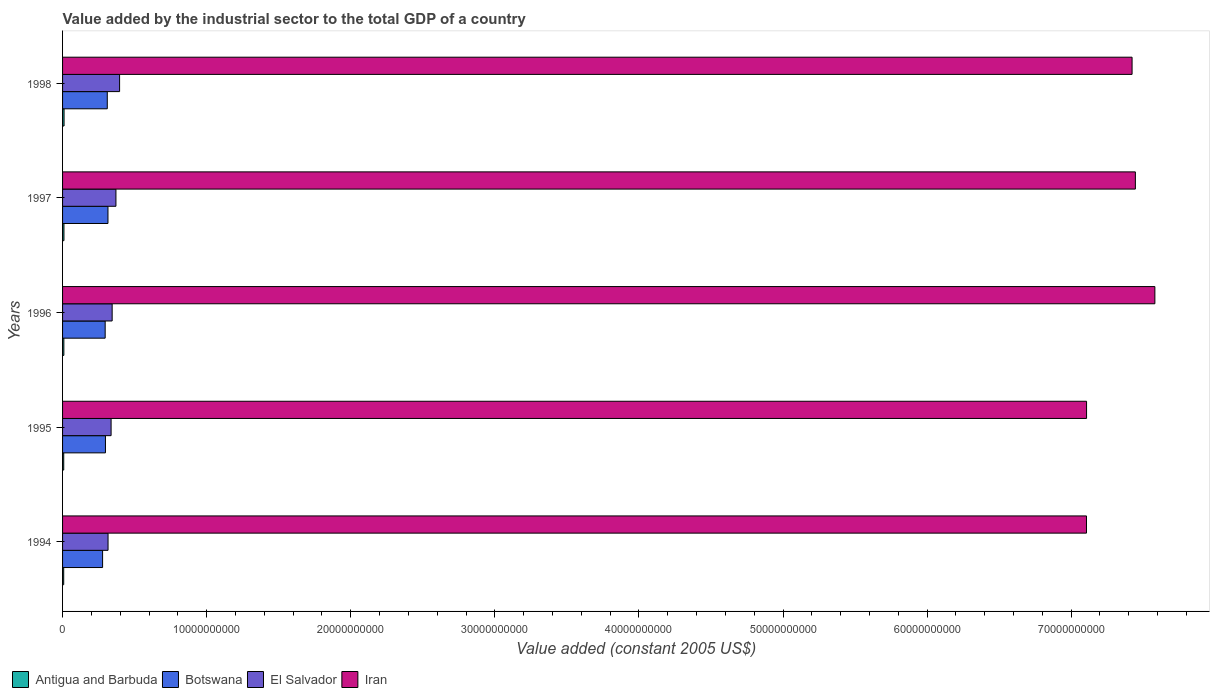Are the number of bars per tick equal to the number of legend labels?
Give a very brief answer. Yes. Are the number of bars on each tick of the Y-axis equal?
Provide a succinct answer. Yes. How many bars are there on the 3rd tick from the top?
Provide a succinct answer. 4. How many bars are there on the 4th tick from the bottom?
Offer a very short reply. 4. In how many cases, is the number of bars for a given year not equal to the number of legend labels?
Your response must be concise. 0. What is the value added by the industrial sector in El Salvador in 1995?
Keep it short and to the point. 3.37e+09. Across all years, what is the maximum value added by the industrial sector in El Salvador?
Offer a very short reply. 3.96e+09. Across all years, what is the minimum value added by the industrial sector in Botswana?
Your response must be concise. 2.78e+09. In which year was the value added by the industrial sector in Antigua and Barbuda minimum?
Make the answer very short. 1994. What is the total value added by the industrial sector in El Salvador in the graph?
Your response must be concise. 1.76e+1. What is the difference between the value added by the industrial sector in El Salvador in 1995 and that in 1996?
Offer a terse response. -7.37e+07. What is the difference between the value added by the industrial sector in Antigua and Barbuda in 1997 and the value added by the industrial sector in Iran in 1995?
Provide a succinct answer. -7.10e+1. What is the average value added by the industrial sector in Antigua and Barbuda per year?
Your response must be concise. 8.99e+07. In the year 1994, what is the difference between the value added by the industrial sector in El Salvador and value added by the industrial sector in Botswana?
Ensure brevity in your answer.  3.79e+08. In how many years, is the value added by the industrial sector in Iran greater than 76000000000 US$?
Make the answer very short. 0. What is the ratio of the value added by the industrial sector in Antigua and Barbuda in 1996 to that in 1997?
Your response must be concise. 0.93. What is the difference between the highest and the second highest value added by the industrial sector in Antigua and Barbuda?
Provide a succinct answer. 7.45e+06. What is the difference between the highest and the lowest value added by the industrial sector in Botswana?
Your response must be concise. 3.73e+08. Is the sum of the value added by the industrial sector in El Salvador in 1994 and 1997 greater than the maximum value added by the industrial sector in Botswana across all years?
Make the answer very short. Yes. Is it the case that in every year, the sum of the value added by the industrial sector in El Salvador and value added by the industrial sector in Botswana is greater than the sum of value added by the industrial sector in Antigua and Barbuda and value added by the industrial sector in Iran?
Provide a short and direct response. Yes. What does the 2nd bar from the top in 1994 represents?
Give a very brief answer. El Salvador. What does the 1st bar from the bottom in 1995 represents?
Ensure brevity in your answer.  Antigua and Barbuda. How many bars are there?
Offer a terse response. 20. What is the difference between two consecutive major ticks on the X-axis?
Your answer should be very brief. 1.00e+1. Does the graph contain any zero values?
Your response must be concise. No. Where does the legend appear in the graph?
Your answer should be compact. Bottom left. How many legend labels are there?
Offer a terse response. 4. What is the title of the graph?
Offer a very short reply. Value added by the industrial sector to the total GDP of a country. Does "Nepal" appear as one of the legend labels in the graph?
Your answer should be very brief. No. What is the label or title of the X-axis?
Offer a terse response. Value added (constant 2005 US$). What is the label or title of the Y-axis?
Make the answer very short. Years. What is the Value added (constant 2005 US$) of Antigua and Barbuda in 1994?
Keep it short and to the point. 7.94e+07. What is the Value added (constant 2005 US$) of Botswana in 1994?
Keep it short and to the point. 2.78e+09. What is the Value added (constant 2005 US$) in El Salvador in 1994?
Your response must be concise. 3.16e+09. What is the Value added (constant 2005 US$) in Iran in 1994?
Keep it short and to the point. 7.11e+1. What is the Value added (constant 2005 US$) of Antigua and Barbuda in 1995?
Ensure brevity in your answer.  8.10e+07. What is the Value added (constant 2005 US$) of Botswana in 1995?
Make the answer very short. 2.98e+09. What is the Value added (constant 2005 US$) of El Salvador in 1995?
Provide a succinct answer. 3.37e+09. What is the Value added (constant 2005 US$) of Iran in 1995?
Make the answer very short. 7.11e+1. What is the Value added (constant 2005 US$) of Antigua and Barbuda in 1996?
Give a very brief answer. 8.97e+07. What is the Value added (constant 2005 US$) in Botswana in 1996?
Keep it short and to the point. 2.96e+09. What is the Value added (constant 2005 US$) of El Salvador in 1996?
Keep it short and to the point. 3.44e+09. What is the Value added (constant 2005 US$) of Iran in 1996?
Make the answer very short. 7.58e+1. What is the Value added (constant 2005 US$) of Antigua and Barbuda in 1997?
Your response must be concise. 9.61e+07. What is the Value added (constant 2005 US$) of Botswana in 1997?
Offer a very short reply. 3.15e+09. What is the Value added (constant 2005 US$) in El Salvador in 1997?
Keep it short and to the point. 3.70e+09. What is the Value added (constant 2005 US$) in Iran in 1997?
Make the answer very short. 7.45e+1. What is the Value added (constant 2005 US$) in Antigua and Barbuda in 1998?
Offer a terse response. 1.04e+08. What is the Value added (constant 2005 US$) in Botswana in 1998?
Keep it short and to the point. 3.10e+09. What is the Value added (constant 2005 US$) of El Salvador in 1998?
Your answer should be very brief. 3.96e+09. What is the Value added (constant 2005 US$) in Iran in 1998?
Provide a short and direct response. 7.42e+1. Across all years, what is the maximum Value added (constant 2005 US$) of Antigua and Barbuda?
Offer a terse response. 1.04e+08. Across all years, what is the maximum Value added (constant 2005 US$) in Botswana?
Your answer should be very brief. 3.15e+09. Across all years, what is the maximum Value added (constant 2005 US$) of El Salvador?
Provide a short and direct response. 3.96e+09. Across all years, what is the maximum Value added (constant 2005 US$) of Iran?
Give a very brief answer. 7.58e+1. Across all years, what is the minimum Value added (constant 2005 US$) in Antigua and Barbuda?
Ensure brevity in your answer.  7.94e+07. Across all years, what is the minimum Value added (constant 2005 US$) of Botswana?
Offer a very short reply. 2.78e+09. Across all years, what is the minimum Value added (constant 2005 US$) of El Salvador?
Your response must be concise. 3.16e+09. Across all years, what is the minimum Value added (constant 2005 US$) of Iran?
Your answer should be very brief. 7.11e+1. What is the total Value added (constant 2005 US$) of Antigua and Barbuda in the graph?
Keep it short and to the point. 4.50e+08. What is the total Value added (constant 2005 US$) of Botswana in the graph?
Provide a short and direct response. 1.50e+1. What is the total Value added (constant 2005 US$) in El Salvador in the graph?
Ensure brevity in your answer.  1.76e+1. What is the total Value added (constant 2005 US$) of Iran in the graph?
Ensure brevity in your answer.  3.67e+11. What is the difference between the Value added (constant 2005 US$) in Antigua and Barbuda in 1994 and that in 1995?
Offer a very short reply. -1.69e+06. What is the difference between the Value added (constant 2005 US$) of Botswana in 1994 and that in 1995?
Ensure brevity in your answer.  -1.98e+08. What is the difference between the Value added (constant 2005 US$) in El Salvador in 1994 and that in 1995?
Ensure brevity in your answer.  -2.11e+08. What is the difference between the Value added (constant 2005 US$) of Iran in 1994 and that in 1995?
Make the answer very short. -5.44e+06. What is the difference between the Value added (constant 2005 US$) of Antigua and Barbuda in 1994 and that in 1996?
Give a very brief answer. -1.03e+07. What is the difference between the Value added (constant 2005 US$) of Botswana in 1994 and that in 1996?
Your answer should be very brief. -1.79e+08. What is the difference between the Value added (constant 2005 US$) in El Salvador in 1994 and that in 1996?
Give a very brief answer. -2.85e+08. What is the difference between the Value added (constant 2005 US$) in Iran in 1994 and that in 1996?
Keep it short and to the point. -4.75e+09. What is the difference between the Value added (constant 2005 US$) of Antigua and Barbuda in 1994 and that in 1997?
Your response must be concise. -1.67e+07. What is the difference between the Value added (constant 2005 US$) in Botswana in 1994 and that in 1997?
Your answer should be compact. -3.73e+08. What is the difference between the Value added (constant 2005 US$) of El Salvador in 1994 and that in 1997?
Your answer should be compact. -5.47e+08. What is the difference between the Value added (constant 2005 US$) in Iran in 1994 and that in 1997?
Provide a short and direct response. -3.39e+09. What is the difference between the Value added (constant 2005 US$) in Antigua and Barbuda in 1994 and that in 1998?
Give a very brief answer. -2.42e+07. What is the difference between the Value added (constant 2005 US$) in Botswana in 1994 and that in 1998?
Offer a very short reply. -3.25e+08. What is the difference between the Value added (constant 2005 US$) in El Salvador in 1994 and that in 1998?
Your answer should be compact. -8.01e+08. What is the difference between the Value added (constant 2005 US$) of Iran in 1994 and that in 1998?
Keep it short and to the point. -3.16e+09. What is the difference between the Value added (constant 2005 US$) of Antigua and Barbuda in 1995 and that in 1996?
Make the answer very short. -8.63e+06. What is the difference between the Value added (constant 2005 US$) of Botswana in 1995 and that in 1996?
Ensure brevity in your answer.  1.96e+07. What is the difference between the Value added (constant 2005 US$) in El Salvador in 1995 and that in 1996?
Provide a short and direct response. -7.37e+07. What is the difference between the Value added (constant 2005 US$) in Iran in 1995 and that in 1996?
Ensure brevity in your answer.  -4.74e+09. What is the difference between the Value added (constant 2005 US$) in Antigua and Barbuda in 1995 and that in 1997?
Ensure brevity in your answer.  -1.50e+07. What is the difference between the Value added (constant 2005 US$) of Botswana in 1995 and that in 1997?
Offer a terse response. -1.75e+08. What is the difference between the Value added (constant 2005 US$) in El Salvador in 1995 and that in 1997?
Provide a succinct answer. -3.36e+08. What is the difference between the Value added (constant 2005 US$) in Iran in 1995 and that in 1997?
Ensure brevity in your answer.  -3.39e+09. What is the difference between the Value added (constant 2005 US$) in Antigua and Barbuda in 1995 and that in 1998?
Your response must be concise. -2.25e+07. What is the difference between the Value added (constant 2005 US$) in Botswana in 1995 and that in 1998?
Ensure brevity in your answer.  -1.27e+08. What is the difference between the Value added (constant 2005 US$) in El Salvador in 1995 and that in 1998?
Keep it short and to the point. -5.90e+08. What is the difference between the Value added (constant 2005 US$) in Iran in 1995 and that in 1998?
Your answer should be compact. -3.16e+09. What is the difference between the Value added (constant 2005 US$) in Antigua and Barbuda in 1996 and that in 1997?
Make the answer very short. -6.40e+06. What is the difference between the Value added (constant 2005 US$) in Botswana in 1996 and that in 1997?
Offer a terse response. -1.94e+08. What is the difference between the Value added (constant 2005 US$) of El Salvador in 1996 and that in 1997?
Your answer should be compact. -2.62e+08. What is the difference between the Value added (constant 2005 US$) in Iran in 1996 and that in 1997?
Offer a very short reply. 1.35e+09. What is the difference between the Value added (constant 2005 US$) in Antigua and Barbuda in 1996 and that in 1998?
Give a very brief answer. -1.38e+07. What is the difference between the Value added (constant 2005 US$) of Botswana in 1996 and that in 1998?
Keep it short and to the point. -1.46e+08. What is the difference between the Value added (constant 2005 US$) in El Salvador in 1996 and that in 1998?
Your response must be concise. -5.16e+08. What is the difference between the Value added (constant 2005 US$) in Iran in 1996 and that in 1998?
Offer a terse response. 1.58e+09. What is the difference between the Value added (constant 2005 US$) of Antigua and Barbuda in 1997 and that in 1998?
Ensure brevity in your answer.  -7.45e+06. What is the difference between the Value added (constant 2005 US$) of Botswana in 1997 and that in 1998?
Give a very brief answer. 4.81e+07. What is the difference between the Value added (constant 2005 US$) in El Salvador in 1997 and that in 1998?
Your answer should be compact. -2.54e+08. What is the difference between the Value added (constant 2005 US$) of Iran in 1997 and that in 1998?
Provide a short and direct response. 2.29e+08. What is the difference between the Value added (constant 2005 US$) in Antigua and Barbuda in 1994 and the Value added (constant 2005 US$) in Botswana in 1995?
Offer a very short reply. -2.90e+09. What is the difference between the Value added (constant 2005 US$) in Antigua and Barbuda in 1994 and the Value added (constant 2005 US$) in El Salvador in 1995?
Offer a terse response. -3.29e+09. What is the difference between the Value added (constant 2005 US$) in Antigua and Barbuda in 1994 and the Value added (constant 2005 US$) in Iran in 1995?
Provide a short and direct response. -7.10e+1. What is the difference between the Value added (constant 2005 US$) in Botswana in 1994 and the Value added (constant 2005 US$) in El Salvador in 1995?
Keep it short and to the point. -5.90e+08. What is the difference between the Value added (constant 2005 US$) in Botswana in 1994 and the Value added (constant 2005 US$) in Iran in 1995?
Your response must be concise. -6.83e+1. What is the difference between the Value added (constant 2005 US$) of El Salvador in 1994 and the Value added (constant 2005 US$) of Iran in 1995?
Your answer should be compact. -6.79e+1. What is the difference between the Value added (constant 2005 US$) of Antigua and Barbuda in 1994 and the Value added (constant 2005 US$) of Botswana in 1996?
Make the answer very short. -2.88e+09. What is the difference between the Value added (constant 2005 US$) of Antigua and Barbuda in 1994 and the Value added (constant 2005 US$) of El Salvador in 1996?
Your response must be concise. -3.36e+09. What is the difference between the Value added (constant 2005 US$) of Antigua and Barbuda in 1994 and the Value added (constant 2005 US$) of Iran in 1996?
Provide a succinct answer. -7.57e+1. What is the difference between the Value added (constant 2005 US$) of Botswana in 1994 and the Value added (constant 2005 US$) of El Salvador in 1996?
Make the answer very short. -6.64e+08. What is the difference between the Value added (constant 2005 US$) of Botswana in 1994 and the Value added (constant 2005 US$) of Iran in 1996?
Ensure brevity in your answer.  -7.30e+1. What is the difference between the Value added (constant 2005 US$) of El Salvador in 1994 and the Value added (constant 2005 US$) of Iran in 1996?
Your response must be concise. -7.27e+1. What is the difference between the Value added (constant 2005 US$) in Antigua and Barbuda in 1994 and the Value added (constant 2005 US$) in Botswana in 1997?
Your answer should be compact. -3.07e+09. What is the difference between the Value added (constant 2005 US$) of Antigua and Barbuda in 1994 and the Value added (constant 2005 US$) of El Salvador in 1997?
Your answer should be compact. -3.62e+09. What is the difference between the Value added (constant 2005 US$) in Antigua and Barbuda in 1994 and the Value added (constant 2005 US$) in Iran in 1997?
Your response must be concise. -7.44e+1. What is the difference between the Value added (constant 2005 US$) of Botswana in 1994 and the Value added (constant 2005 US$) of El Salvador in 1997?
Make the answer very short. -9.26e+08. What is the difference between the Value added (constant 2005 US$) of Botswana in 1994 and the Value added (constant 2005 US$) of Iran in 1997?
Provide a short and direct response. -7.17e+1. What is the difference between the Value added (constant 2005 US$) in El Salvador in 1994 and the Value added (constant 2005 US$) in Iran in 1997?
Your answer should be compact. -7.13e+1. What is the difference between the Value added (constant 2005 US$) in Antigua and Barbuda in 1994 and the Value added (constant 2005 US$) in Botswana in 1998?
Give a very brief answer. -3.02e+09. What is the difference between the Value added (constant 2005 US$) in Antigua and Barbuda in 1994 and the Value added (constant 2005 US$) in El Salvador in 1998?
Give a very brief answer. -3.88e+09. What is the difference between the Value added (constant 2005 US$) of Antigua and Barbuda in 1994 and the Value added (constant 2005 US$) of Iran in 1998?
Offer a terse response. -7.41e+1. What is the difference between the Value added (constant 2005 US$) of Botswana in 1994 and the Value added (constant 2005 US$) of El Salvador in 1998?
Your response must be concise. -1.18e+09. What is the difference between the Value added (constant 2005 US$) in Botswana in 1994 and the Value added (constant 2005 US$) in Iran in 1998?
Your response must be concise. -7.14e+1. What is the difference between the Value added (constant 2005 US$) in El Salvador in 1994 and the Value added (constant 2005 US$) in Iran in 1998?
Make the answer very short. -7.11e+1. What is the difference between the Value added (constant 2005 US$) of Antigua and Barbuda in 1995 and the Value added (constant 2005 US$) of Botswana in 1996?
Make the answer very short. -2.88e+09. What is the difference between the Value added (constant 2005 US$) in Antigua and Barbuda in 1995 and the Value added (constant 2005 US$) in El Salvador in 1996?
Offer a terse response. -3.36e+09. What is the difference between the Value added (constant 2005 US$) of Antigua and Barbuda in 1995 and the Value added (constant 2005 US$) of Iran in 1996?
Keep it short and to the point. -7.57e+1. What is the difference between the Value added (constant 2005 US$) in Botswana in 1995 and the Value added (constant 2005 US$) in El Salvador in 1996?
Offer a terse response. -4.66e+08. What is the difference between the Value added (constant 2005 US$) of Botswana in 1995 and the Value added (constant 2005 US$) of Iran in 1996?
Your answer should be very brief. -7.28e+1. What is the difference between the Value added (constant 2005 US$) of El Salvador in 1995 and the Value added (constant 2005 US$) of Iran in 1996?
Keep it short and to the point. -7.24e+1. What is the difference between the Value added (constant 2005 US$) in Antigua and Barbuda in 1995 and the Value added (constant 2005 US$) in Botswana in 1997?
Offer a terse response. -3.07e+09. What is the difference between the Value added (constant 2005 US$) of Antigua and Barbuda in 1995 and the Value added (constant 2005 US$) of El Salvador in 1997?
Your answer should be compact. -3.62e+09. What is the difference between the Value added (constant 2005 US$) in Antigua and Barbuda in 1995 and the Value added (constant 2005 US$) in Iran in 1997?
Give a very brief answer. -7.44e+1. What is the difference between the Value added (constant 2005 US$) of Botswana in 1995 and the Value added (constant 2005 US$) of El Salvador in 1997?
Give a very brief answer. -7.28e+08. What is the difference between the Value added (constant 2005 US$) of Botswana in 1995 and the Value added (constant 2005 US$) of Iran in 1997?
Make the answer very short. -7.15e+1. What is the difference between the Value added (constant 2005 US$) in El Salvador in 1995 and the Value added (constant 2005 US$) in Iran in 1997?
Provide a short and direct response. -7.11e+1. What is the difference between the Value added (constant 2005 US$) in Antigua and Barbuda in 1995 and the Value added (constant 2005 US$) in Botswana in 1998?
Provide a short and direct response. -3.02e+09. What is the difference between the Value added (constant 2005 US$) in Antigua and Barbuda in 1995 and the Value added (constant 2005 US$) in El Salvador in 1998?
Your answer should be very brief. -3.88e+09. What is the difference between the Value added (constant 2005 US$) in Antigua and Barbuda in 1995 and the Value added (constant 2005 US$) in Iran in 1998?
Your answer should be compact. -7.41e+1. What is the difference between the Value added (constant 2005 US$) of Botswana in 1995 and the Value added (constant 2005 US$) of El Salvador in 1998?
Offer a terse response. -9.82e+08. What is the difference between the Value added (constant 2005 US$) in Botswana in 1995 and the Value added (constant 2005 US$) in Iran in 1998?
Provide a succinct answer. -7.13e+1. What is the difference between the Value added (constant 2005 US$) of El Salvador in 1995 and the Value added (constant 2005 US$) of Iran in 1998?
Provide a succinct answer. -7.09e+1. What is the difference between the Value added (constant 2005 US$) in Antigua and Barbuda in 1996 and the Value added (constant 2005 US$) in Botswana in 1997?
Keep it short and to the point. -3.06e+09. What is the difference between the Value added (constant 2005 US$) in Antigua and Barbuda in 1996 and the Value added (constant 2005 US$) in El Salvador in 1997?
Keep it short and to the point. -3.61e+09. What is the difference between the Value added (constant 2005 US$) of Antigua and Barbuda in 1996 and the Value added (constant 2005 US$) of Iran in 1997?
Provide a short and direct response. -7.44e+1. What is the difference between the Value added (constant 2005 US$) in Botswana in 1996 and the Value added (constant 2005 US$) in El Salvador in 1997?
Give a very brief answer. -7.47e+08. What is the difference between the Value added (constant 2005 US$) of Botswana in 1996 and the Value added (constant 2005 US$) of Iran in 1997?
Keep it short and to the point. -7.15e+1. What is the difference between the Value added (constant 2005 US$) in El Salvador in 1996 and the Value added (constant 2005 US$) in Iran in 1997?
Provide a succinct answer. -7.10e+1. What is the difference between the Value added (constant 2005 US$) of Antigua and Barbuda in 1996 and the Value added (constant 2005 US$) of Botswana in 1998?
Ensure brevity in your answer.  -3.01e+09. What is the difference between the Value added (constant 2005 US$) in Antigua and Barbuda in 1996 and the Value added (constant 2005 US$) in El Salvador in 1998?
Provide a succinct answer. -3.87e+09. What is the difference between the Value added (constant 2005 US$) of Antigua and Barbuda in 1996 and the Value added (constant 2005 US$) of Iran in 1998?
Your response must be concise. -7.41e+1. What is the difference between the Value added (constant 2005 US$) of Botswana in 1996 and the Value added (constant 2005 US$) of El Salvador in 1998?
Your response must be concise. -1.00e+09. What is the difference between the Value added (constant 2005 US$) in Botswana in 1996 and the Value added (constant 2005 US$) in Iran in 1998?
Offer a very short reply. -7.13e+1. What is the difference between the Value added (constant 2005 US$) in El Salvador in 1996 and the Value added (constant 2005 US$) in Iran in 1998?
Your answer should be compact. -7.08e+1. What is the difference between the Value added (constant 2005 US$) in Antigua and Barbuda in 1997 and the Value added (constant 2005 US$) in Botswana in 1998?
Keep it short and to the point. -3.01e+09. What is the difference between the Value added (constant 2005 US$) in Antigua and Barbuda in 1997 and the Value added (constant 2005 US$) in El Salvador in 1998?
Give a very brief answer. -3.86e+09. What is the difference between the Value added (constant 2005 US$) of Antigua and Barbuda in 1997 and the Value added (constant 2005 US$) of Iran in 1998?
Give a very brief answer. -7.41e+1. What is the difference between the Value added (constant 2005 US$) of Botswana in 1997 and the Value added (constant 2005 US$) of El Salvador in 1998?
Provide a short and direct response. -8.07e+08. What is the difference between the Value added (constant 2005 US$) in Botswana in 1997 and the Value added (constant 2005 US$) in Iran in 1998?
Provide a succinct answer. -7.11e+1. What is the difference between the Value added (constant 2005 US$) in El Salvador in 1997 and the Value added (constant 2005 US$) in Iran in 1998?
Make the answer very short. -7.05e+1. What is the average Value added (constant 2005 US$) in Antigua and Barbuda per year?
Give a very brief answer. 8.99e+07. What is the average Value added (constant 2005 US$) in Botswana per year?
Keep it short and to the point. 2.99e+09. What is the average Value added (constant 2005 US$) of El Salvador per year?
Your response must be concise. 3.53e+09. What is the average Value added (constant 2005 US$) in Iran per year?
Your answer should be very brief. 7.33e+1. In the year 1994, what is the difference between the Value added (constant 2005 US$) in Antigua and Barbuda and Value added (constant 2005 US$) in Botswana?
Make the answer very short. -2.70e+09. In the year 1994, what is the difference between the Value added (constant 2005 US$) of Antigua and Barbuda and Value added (constant 2005 US$) of El Salvador?
Provide a succinct answer. -3.08e+09. In the year 1994, what is the difference between the Value added (constant 2005 US$) of Antigua and Barbuda and Value added (constant 2005 US$) of Iran?
Keep it short and to the point. -7.10e+1. In the year 1994, what is the difference between the Value added (constant 2005 US$) in Botswana and Value added (constant 2005 US$) in El Salvador?
Offer a terse response. -3.79e+08. In the year 1994, what is the difference between the Value added (constant 2005 US$) in Botswana and Value added (constant 2005 US$) in Iran?
Offer a very short reply. -6.83e+1. In the year 1994, what is the difference between the Value added (constant 2005 US$) of El Salvador and Value added (constant 2005 US$) of Iran?
Your answer should be compact. -6.79e+1. In the year 1995, what is the difference between the Value added (constant 2005 US$) of Antigua and Barbuda and Value added (constant 2005 US$) of Botswana?
Your answer should be compact. -2.90e+09. In the year 1995, what is the difference between the Value added (constant 2005 US$) in Antigua and Barbuda and Value added (constant 2005 US$) in El Salvador?
Give a very brief answer. -3.29e+09. In the year 1995, what is the difference between the Value added (constant 2005 US$) in Antigua and Barbuda and Value added (constant 2005 US$) in Iran?
Provide a short and direct response. -7.10e+1. In the year 1995, what is the difference between the Value added (constant 2005 US$) of Botswana and Value added (constant 2005 US$) of El Salvador?
Your response must be concise. -3.92e+08. In the year 1995, what is the difference between the Value added (constant 2005 US$) in Botswana and Value added (constant 2005 US$) in Iran?
Provide a short and direct response. -6.81e+1. In the year 1995, what is the difference between the Value added (constant 2005 US$) in El Salvador and Value added (constant 2005 US$) in Iran?
Offer a terse response. -6.77e+1. In the year 1996, what is the difference between the Value added (constant 2005 US$) of Antigua and Barbuda and Value added (constant 2005 US$) of Botswana?
Keep it short and to the point. -2.87e+09. In the year 1996, what is the difference between the Value added (constant 2005 US$) in Antigua and Barbuda and Value added (constant 2005 US$) in El Salvador?
Provide a short and direct response. -3.35e+09. In the year 1996, what is the difference between the Value added (constant 2005 US$) in Antigua and Barbuda and Value added (constant 2005 US$) in Iran?
Provide a short and direct response. -7.57e+1. In the year 1996, what is the difference between the Value added (constant 2005 US$) in Botswana and Value added (constant 2005 US$) in El Salvador?
Offer a terse response. -4.85e+08. In the year 1996, what is the difference between the Value added (constant 2005 US$) of Botswana and Value added (constant 2005 US$) of Iran?
Your response must be concise. -7.29e+1. In the year 1996, what is the difference between the Value added (constant 2005 US$) in El Salvador and Value added (constant 2005 US$) in Iran?
Ensure brevity in your answer.  -7.24e+1. In the year 1997, what is the difference between the Value added (constant 2005 US$) in Antigua and Barbuda and Value added (constant 2005 US$) in Botswana?
Your response must be concise. -3.05e+09. In the year 1997, what is the difference between the Value added (constant 2005 US$) in Antigua and Barbuda and Value added (constant 2005 US$) in El Salvador?
Keep it short and to the point. -3.61e+09. In the year 1997, what is the difference between the Value added (constant 2005 US$) of Antigua and Barbuda and Value added (constant 2005 US$) of Iran?
Your response must be concise. -7.44e+1. In the year 1997, what is the difference between the Value added (constant 2005 US$) of Botswana and Value added (constant 2005 US$) of El Salvador?
Your answer should be very brief. -5.53e+08. In the year 1997, what is the difference between the Value added (constant 2005 US$) of Botswana and Value added (constant 2005 US$) of Iran?
Your answer should be very brief. -7.13e+1. In the year 1997, what is the difference between the Value added (constant 2005 US$) of El Salvador and Value added (constant 2005 US$) of Iran?
Keep it short and to the point. -7.08e+1. In the year 1998, what is the difference between the Value added (constant 2005 US$) in Antigua and Barbuda and Value added (constant 2005 US$) in Botswana?
Give a very brief answer. -3.00e+09. In the year 1998, what is the difference between the Value added (constant 2005 US$) in Antigua and Barbuda and Value added (constant 2005 US$) in El Salvador?
Keep it short and to the point. -3.85e+09. In the year 1998, what is the difference between the Value added (constant 2005 US$) of Antigua and Barbuda and Value added (constant 2005 US$) of Iran?
Your response must be concise. -7.41e+1. In the year 1998, what is the difference between the Value added (constant 2005 US$) in Botswana and Value added (constant 2005 US$) in El Salvador?
Provide a succinct answer. -8.55e+08. In the year 1998, what is the difference between the Value added (constant 2005 US$) of Botswana and Value added (constant 2005 US$) of Iran?
Your answer should be very brief. -7.11e+1. In the year 1998, what is the difference between the Value added (constant 2005 US$) in El Salvador and Value added (constant 2005 US$) in Iran?
Your response must be concise. -7.03e+1. What is the ratio of the Value added (constant 2005 US$) in Antigua and Barbuda in 1994 to that in 1995?
Your response must be concise. 0.98. What is the ratio of the Value added (constant 2005 US$) of Botswana in 1994 to that in 1995?
Offer a very short reply. 0.93. What is the ratio of the Value added (constant 2005 US$) of El Salvador in 1994 to that in 1995?
Give a very brief answer. 0.94. What is the ratio of the Value added (constant 2005 US$) of Antigua and Barbuda in 1994 to that in 1996?
Ensure brevity in your answer.  0.89. What is the ratio of the Value added (constant 2005 US$) of Botswana in 1994 to that in 1996?
Your answer should be very brief. 0.94. What is the ratio of the Value added (constant 2005 US$) of El Salvador in 1994 to that in 1996?
Give a very brief answer. 0.92. What is the ratio of the Value added (constant 2005 US$) of Iran in 1994 to that in 1996?
Your answer should be very brief. 0.94. What is the ratio of the Value added (constant 2005 US$) of Antigua and Barbuda in 1994 to that in 1997?
Provide a short and direct response. 0.83. What is the ratio of the Value added (constant 2005 US$) of Botswana in 1994 to that in 1997?
Ensure brevity in your answer.  0.88. What is the ratio of the Value added (constant 2005 US$) of El Salvador in 1994 to that in 1997?
Offer a terse response. 0.85. What is the ratio of the Value added (constant 2005 US$) in Iran in 1994 to that in 1997?
Make the answer very short. 0.95. What is the ratio of the Value added (constant 2005 US$) in Antigua and Barbuda in 1994 to that in 1998?
Your answer should be compact. 0.77. What is the ratio of the Value added (constant 2005 US$) of Botswana in 1994 to that in 1998?
Your answer should be compact. 0.9. What is the ratio of the Value added (constant 2005 US$) of El Salvador in 1994 to that in 1998?
Offer a terse response. 0.8. What is the ratio of the Value added (constant 2005 US$) of Iran in 1994 to that in 1998?
Give a very brief answer. 0.96. What is the ratio of the Value added (constant 2005 US$) of Antigua and Barbuda in 1995 to that in 1996?
Your response must be concise. 0.9. What is the ratio of the Value added (constant 2005 US$) in Botswana in 1995 to that in 1996?
Your response must be concise. 1.01. What is the ratio of the Value added (constant 2005 US$) of El Salvador in 1995 to that in 1996?
Your response must be concise. 0.98. What is the ratio of the Value added (constant 2005 US$) of Antigua and Barbuda in 1995 to that in 1997?
Offer a terse response. 0.84. What is the ratio of the Value added (constant 2005 US$) of Botswana in 1995 to that in 1997?
Ensure brevity in your answer.  0.94. What is the ratio of the Value added (constant 2005 US$) of El Salvador in 1995 to that in 1997?
Make the answer very short. 0.91. What is the ratio of the Value added (constant 2005 US$) in Iran in 1995 to that in 1997?
Give a very brief answer. 0.95. What is the ratio of the Value added (constant 2005 US$) of Antigua and Barbuda in 1995 to that in 1998?
Your response must be concise. 0.78. What is the ratio of the Value added (constant 2005 US$) of Botswana in 1995 to that in 1998?
Make the answer very short. 0.96. What is the ratio of the Value added (constant 2005 US$) in El Salvador in 1995 to that in 1998?
Make the answer very short. 0.85. What is the ratio of the Value added (constant 2005 US$) of Iran in 1995 to that in 1998?
Ensure brevity in your answer.  0.96. What is the ratio of the Value added (constant 2005 US$) of Antigua and Barbuda in 1996 to that in 1997?
Ensure brevity in your answer.  0.93. What is the ratio of the Value added (constant 2005 US$) of Botswana in 1996 to that in 1997?
Keep it short and to the point. 0.94. What is the ratio of the Value added (constant 2005 US$) in El Salvador in 1996 to that in 1997?
Make the answer very short. 0.93. What is the ratio of the Value added (constant 2005 US$) in Iran in 1996 to that in 1997?
Give a very brief answer. 1.02. What is the ratio of the Value added (constant 2005 US$) of Antigua and Barbuda in 1996 to that in 1998?
Offer a very short reply. 0.87. What is the ratio of the Value added (constant 2005 US$) of Botswana in 1996 to that in 1998?
Your answer should be compact. 0.95. What is the ratio of the Value added (constant 2005 US$) in El Salvador in 1996 to that in 1998?
Provide a succinct answer. 0.87. What is the ratio of the Value added (constant 2005 US$) in Iran in 1996 to that in 1998?
Offer a very short reply. 1.02. What is the ratio of the Value added (constant 2005 US$) in Antigua and Barbuda in 1997 to that in 1998?
Ensure brevity in your answer.  0.93. What is the ratio of the Value added (constant 2005 US$) in Botswana in 1997 to that in 1998?
Keep it short and to the point. 1.02. What is the ratio of the Value added (constant 2005 US$) in El Salvador in 1997 to that in 1998?
Your response must be concise. 0.94. What is the ratio of the Value added (constant 2005 US$) of Iran in 1997 to that in 1998?
Provide a succinct answer. 1. What is the difference between the highest and the second highest Value added (constant 2005 US$) of Antigua and Barbuda?
Keep it short and to the point. 7.45e+06. What is the difference between the highest and the second highest Value added (constant 2005 US$) in Botswana?
Offer a very short reply. 4.81e+07. What is the difference between the highest and the second highest Value added (constant 2005 US$) in El Salvador?
Your answer should be compact. 2.54e+08. What is the difference between the highest and the second highest Value added (constant 2005 US$) in Iran?
Your answer should be compact. 1.35e+09. What is the difference between the highest and the lowest Value added (constant 2005 US$) in Antigua and Barbuda?
Provide a short and direct response. 2.42e+07. What is the difference between the highest and the lowest Value added (constant 2005 US$) in Botswana?
Offer a terse response. 3.73e+08. What is the difference between the highest and the lowest Value added (constant 2005 US$) in El Salvador?
Keep it short and to the point. 8.01e+08. What is the difference between the highest and the lowest Value added (constant 2005 US$) in Iran?
Ensure brevity in your answer.  4.75e+09. 